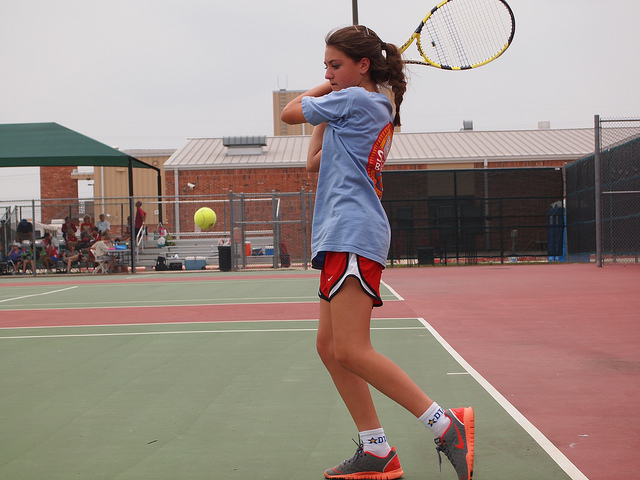Please transcribe the text in this image. 8 